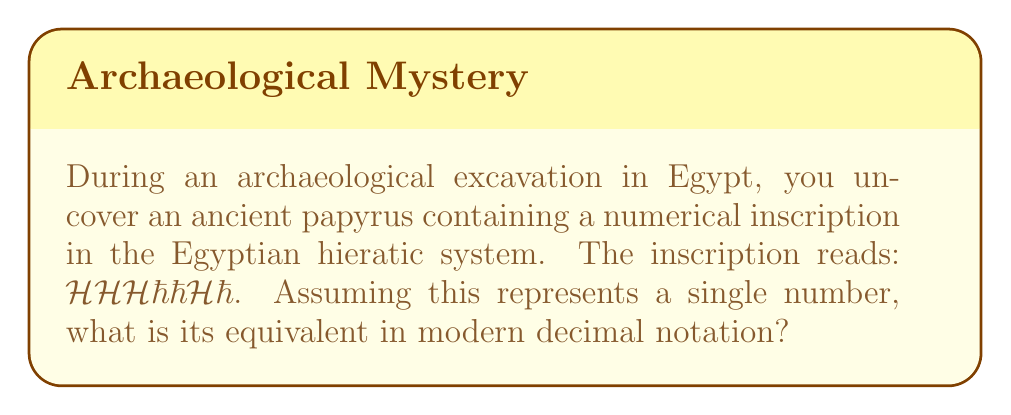Show me your answer to this math problem. To solve this problem, we need to understand the Egyptian hieratic numerical system and convert it to our modern decimal system. Let's break it down step-by-step:

1. In the Egyptian hieratic system:
   - 𓎆 represents 100
   - 𓏻 represents 10

2. The number in the inscription can be written as:
   $$(100 + 100 + 100) + (10 + 10) + 100 + 10$$

3. Let's group the like terms:
   $$(3 \times 100) + (3 \times 10) + 100$$

4. Now, let's calculate:
   $$300 + 30 + 100$$

5. Adding these numbers:
   $$300 + 30 + 100 = 430$$

Therefore, the Egyptian hieratic number 𓎆𓎆𓎆𓏻𓏻𓎆𓏻 is equivalent to 430 in our modern decimal system.
Answer: 430 